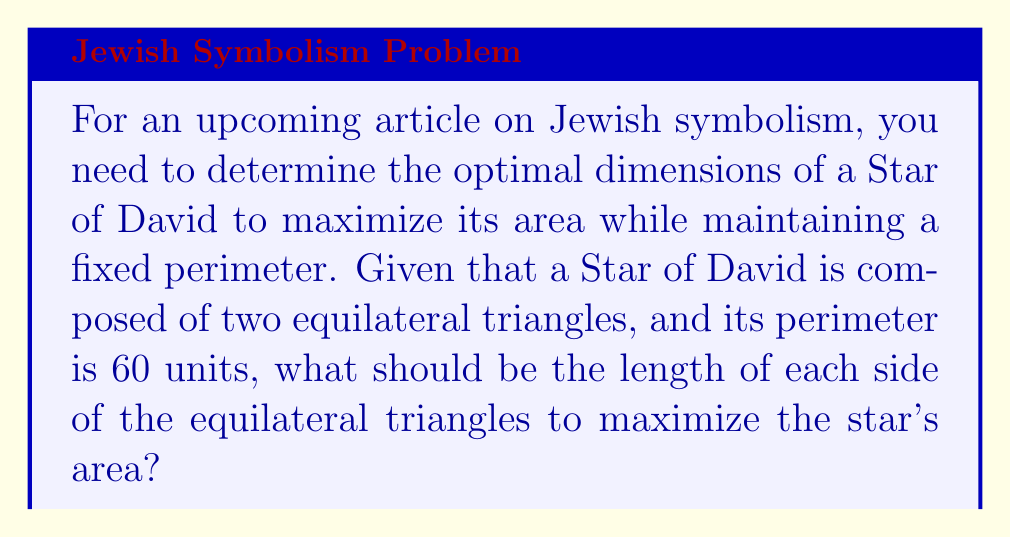Can you answer this question? Let's approach this step-by-step:

1) First, let's define our variables:
   Let $s$ be the side length of each equilateral triangle.

2) The perimeter of the Star of David is given as 60 units. Since the star is made up of 12 equal sides (6 from each triangle), we can write:

   $$12s = 60$$
   $$s = 5$$

3) Now, we need to calculate the area of the Star of David. It's composed of two equilateral triangles, so we'll calculate the area of one triangle and multiply by 2.

4) The area of an equilateral triangle with side length $s$ is given by:

   $$A_{\text{triangle}} = \frac{\sqrt{3}}{4}s^2$$

5) Therefore, the area of the Star of David is:

   $$A_{\text{star}} = 2 \cdot \frac{\sqrt{3}}{4}s^2 = \frac{\sqrt{3}}{2}s^2$$

6) Substituting $s = 5$:

   $$A_{\text{star}} = \frac{\sqrt{3}}{2} \cdot 5^2 = \frac{25\sqrt{3}}{2} \approx 21.65$$

7) To verify this is indeed the maximum area, we can consider slightly larger or smaller values of $s$, keeping the perimeter constant. Any deviation from $s = 5$ will result in a smaller area.

[asy]
unitsize(10mm);
pair A = (0,0), B = (1,0), C = (0.5, 0.866);
pair D = (0.5, 0.289), E = (0.75, 0.433), F = (0.25, 0.433);
draw(A--B--C--cycle, blue);
draw(D--E--F--cycle, blue);
label("$s$", (A+B)/2, S);
[/asy]
Answer: $s = 5$ units 